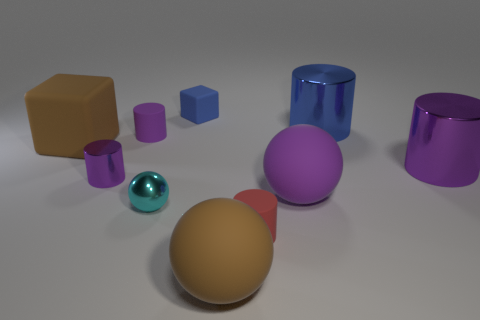Subtract all large purple cylinders. How many cylinders are left? 4 Subtract 2 cylinders. How many cylinders are left? 3 Subtract all brown blocks. How many blocks are left? 1 Subtract all blocks. How many objects are left? 8 Add 7 big balls. How many big balls are left? 9 Add 1 large purple metal things. How many large purple metal things exist? 2 Subtract 0 yellow blocks. How many objects are left? 10 Subtract all blue balls. Subtract all green cylinders. How many balls are left? 3 Subtract all yellow cubes. How many blue cylinders are left? 1 Subtract all small metallic blocks. Subtract all rubber balls. How many objects are left? 8 